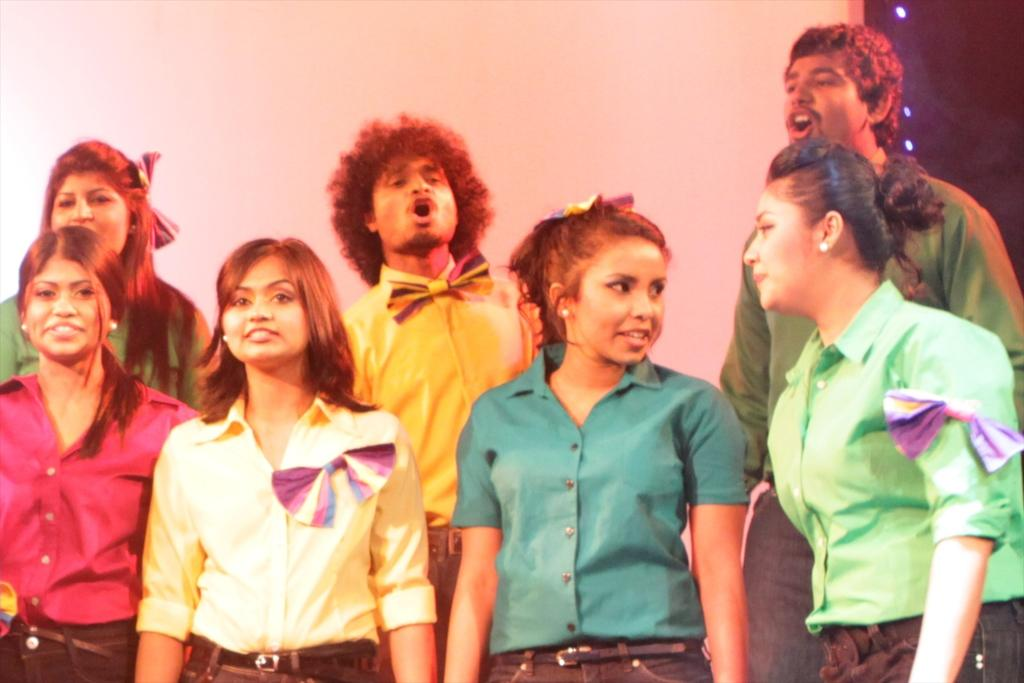What is the main subject of the image? The main subject of the image is a group of people. What are the people in the image doing? The people are standing. What are the people wearing in the image? The people are wearing shirts. Are the shirts the same color or different colors? The shirts have different colors. What type of steel is being used to build the friendship among the people in the image? There is no steel present in the image, and the people's friendship is not being built with any material. 